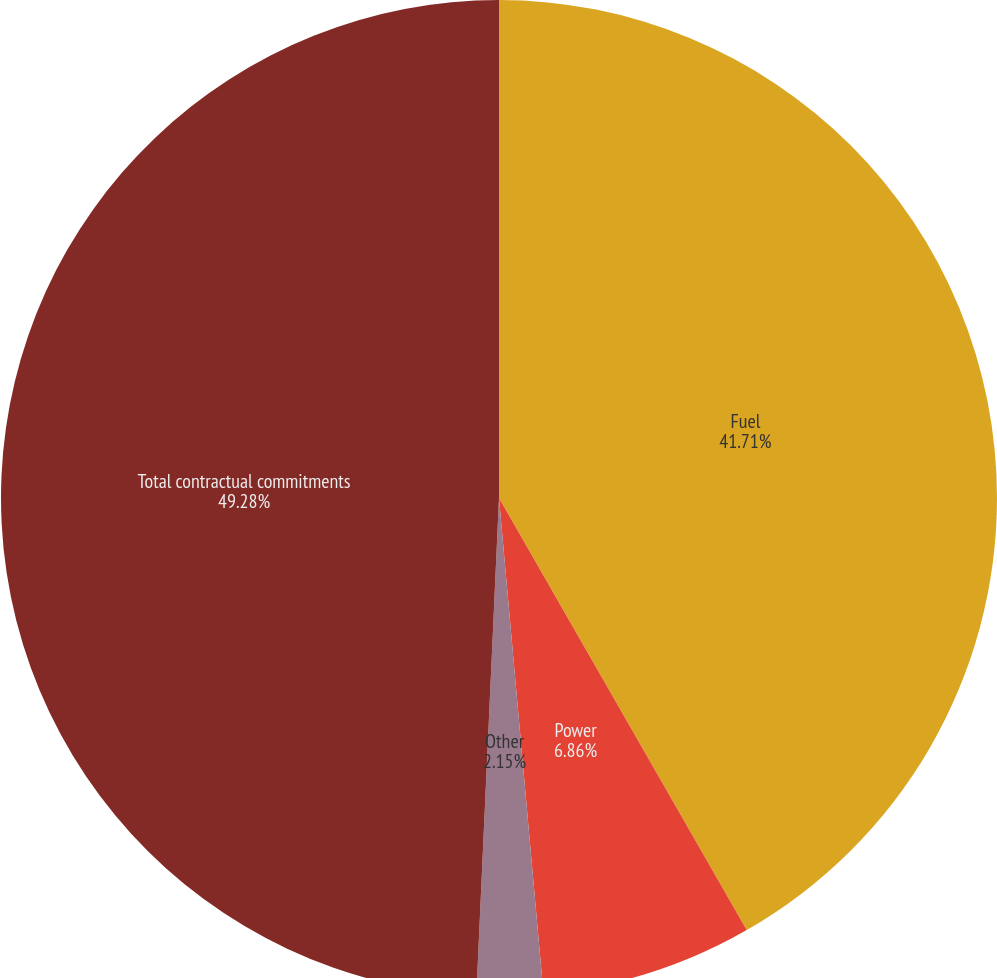Convert chart to OTSL. <chart><loc_0><loc_0><loc_500><loc_500><pie_chart><fcel>Fuel<fcel>Power<fcel>Other<fcel>Total contractual commitments<nl><fcel>41.71%<fcel>6.86%<fcel>2.15%<fcel>49.27%<nl></chart> 